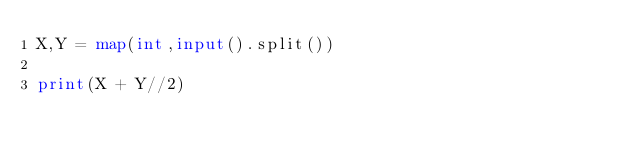<code> <loc_0><loc_0><loc_500><loc_500><_Python_>X,Y = map(int,input().split())

print(X + Y//2)</code> 